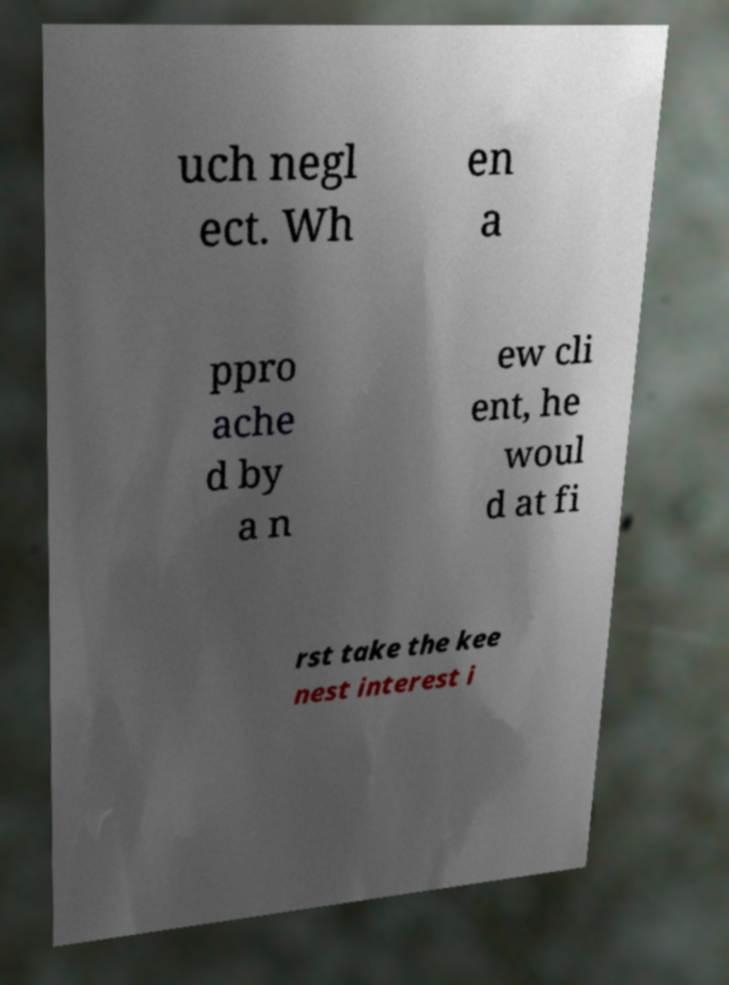Can you read and provide the text displayed in the image?This photo seems to have some interesting text. Can you extract and type it out for me? uch negl ect. Wh en a ppro ache d by a n ew cli ent, he woul d at fi rst take the kee nest interest i 